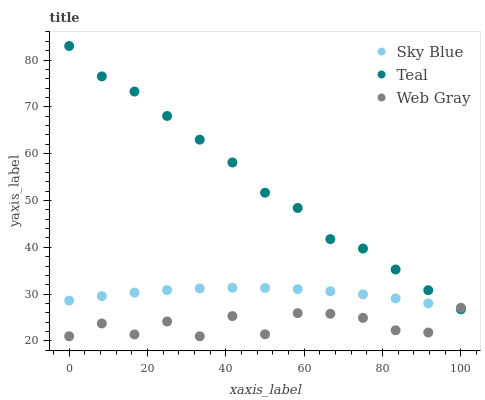Does Web Gray have the minimum area under the curve?
Answer yes or no. Yes. Does Teal have the maximum area under the curve?
Answer yes or no. Yes. Does Teal have the minimum area under the curve?
Answer yes or no. No. Does Web Gray have the maximum area under the curve?
Answer yes or no. No. Is Sky Blue the smoothest?
Answer yes or no. Yes. Is Web Gray the roughest?
Answer yes or no. Yes. Is Teal the smoothest?
Answer yes or no. No. Is Teal the roughest?
Answer yes or no. No. Does Web Gray have the lowest value?
Answer yes or no. Yes. Does Teal have the lowest value?
Answer yes or no. No. Does Teal have the highest value?
Answer yes or no. Yes. Does Web Gray have the highest value?
Answer yes or no. No. Is Sky Blue less than Teal?
Answer yes or no. Yes. Is Teal greater than Sky Blue?
Answer yes or no. Yes. Does Web Gray intersect Teal?
Answer yes or no. Yes. Is Web Gray less than Teal?
Answer yes or no. No. Is Web Gray greater than Teal?
Answer yes or no. No. Does Sky Blue intersect Teal?
Answer yes or no. No. 